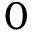<formula> <loc_0><loc_0><loc_500><loc_500>0</formula> 